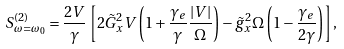<formula> <loc_0><loc_0><loc_500><loc_500>S ^ { ( 2 ) } _ { \omega = \omega _ { 0 } } = \frac { 2 V } { \gamma } \left [ 2 \tilde { G } _ { x } ^ { 2 } V \left ( 1 + \frac { \gamma _ { e } } { \gamma } \frac { | V | } { \Omega } \right ) - \tilde { g } _ { x } ^ { 2 } \Omega \left ( 1 - \frac { \gamma _ { e } } { 2 \gamma } \right ) \right ] ,</formula> 